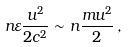<formula> <loc_0><loc_0><loc_500><loc_500>n \varepsilon \frac { u ^ { 2 } } { 2 c ^ { 2 } } \sim n \frac { m u ^ { 2 } } { 2 } \, ,</formula> 